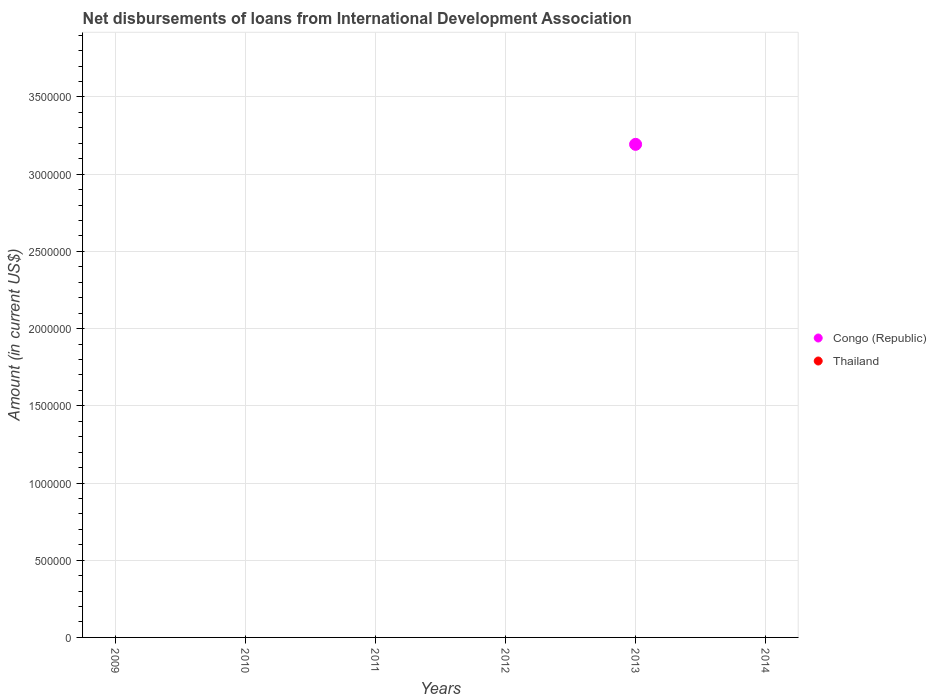Is the number of dotlines equal to the number of legend labels?
Provide a short and direct response. No. Across all years, what is the maximum amount of loans disbursed in Congo (Republic)?
Your answer should be very brief. 3.19e+06. Across all years, what is the minimum amount of loans disbursed in Thailand?
Provide a succinct answer. 0. What is the total amount of loans disbursed in Thailand in the graph?
Your response must be concise. 0. What is the difference between the amount of loans disbursed in Thailand in 2013 and the amount of loans disbursed in Congo (Republic) in 2009?
Give a very brief answer. 0. What is the average amount of loans disbursed in Congo (Republic) per year?
Your answer should be very brief. 5.32e+05. What is the difference between the highest and the lowest amount of loans disbursed in Congo (Republic)?
Give a very brief answer. 3.19e+06. In how many years, is the amount of loans disbursed in Thailand greater than the average amount of loans disbursed in Thailand taken over all years?
Offer a terse response. 0. Is the amount of loans disbursed in Thailand strictly greater than the amount of loans disbursed in Congo (Republic) over the years?
Provide a short and direct response. No. How many legend labels are there?
Your answer should be very brief. 2. What is the title of the graph?
Offer a terse response. Net disbursements of loans from International Development Association. What is the label or title of the Y-axis?
Make the answer very short. Amount (in current US$). What is the Amount (in current US$) of Congo (Republic) in 2009?
Provide a short and direct response. 0. What is the Amount (in current US$) of Congo (Republic) in 2011?
Your answer should be compact. 0. What is the Amount (in current US$) of Congo (Republic) in 2012?
Offer a terse response. 0. What is the Amount (in current US$) of Congo (Republic) in 2013?
Ensure brevity in your answer.  3.19e+06. What is the Amount (in current US$) in Congo (Republic) in 2014?
Offer a very short reply. 0. What is the Amount (in current US$) in Thailand in 2014?
Make the answer very short. 0. Across all years, what is the maximum Amount (in current US$) of Congo (Republic)?
Provide a short and direct response. 3.19e+06. Across all years, what is the minimum Amount (in current US$) of Congo (Republic)?
Make the answer very short. 0. What is the total Amount (in current US$) of Congo (Republic) in the graph?
Ensure brevity in your answer.  3.19e+06. What is the average Amount (in current US$) of Congo (Republic) per year?
Ensure brevity in your answer.  5.32e+05. What is the difference between the highest and the lowest Amount (in current US$) in Congo (Republic)?
Offer a terse response. 3.19e+06. 